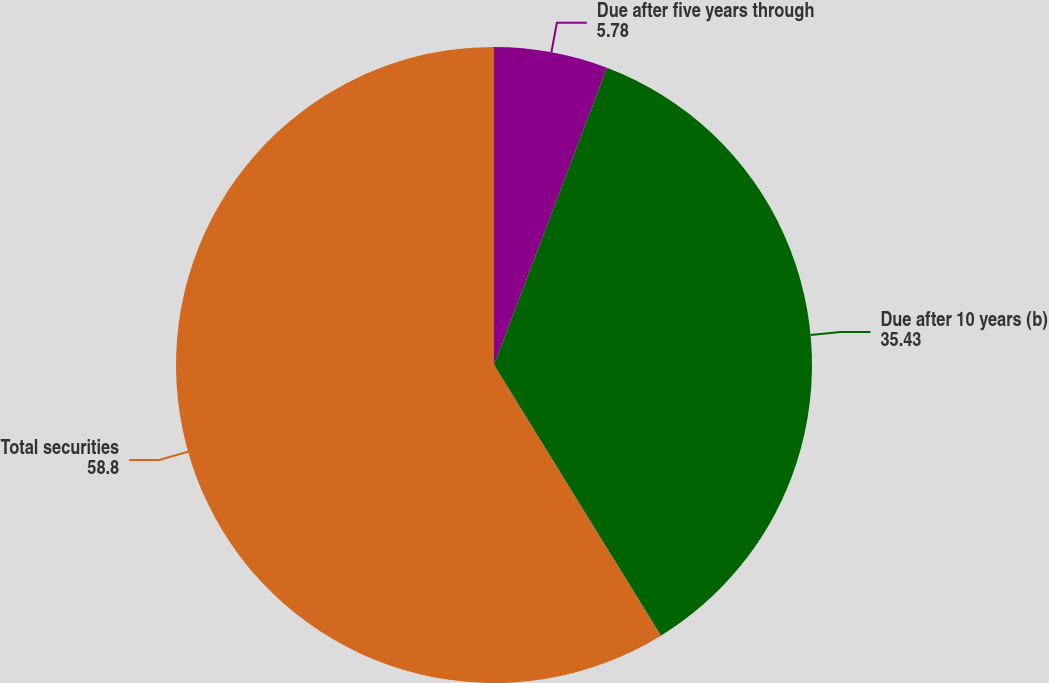Convert chart to OTSL. <chart><loc_0><loc_0><loc_500><loc_500><pie_chart><fcel>Due after five years through<fcel>Due after 10 years (b)<fcel>Total securities<nl><fcel>5.78%<fcel>35.43%<fcel>58.8%<nl></chart> 